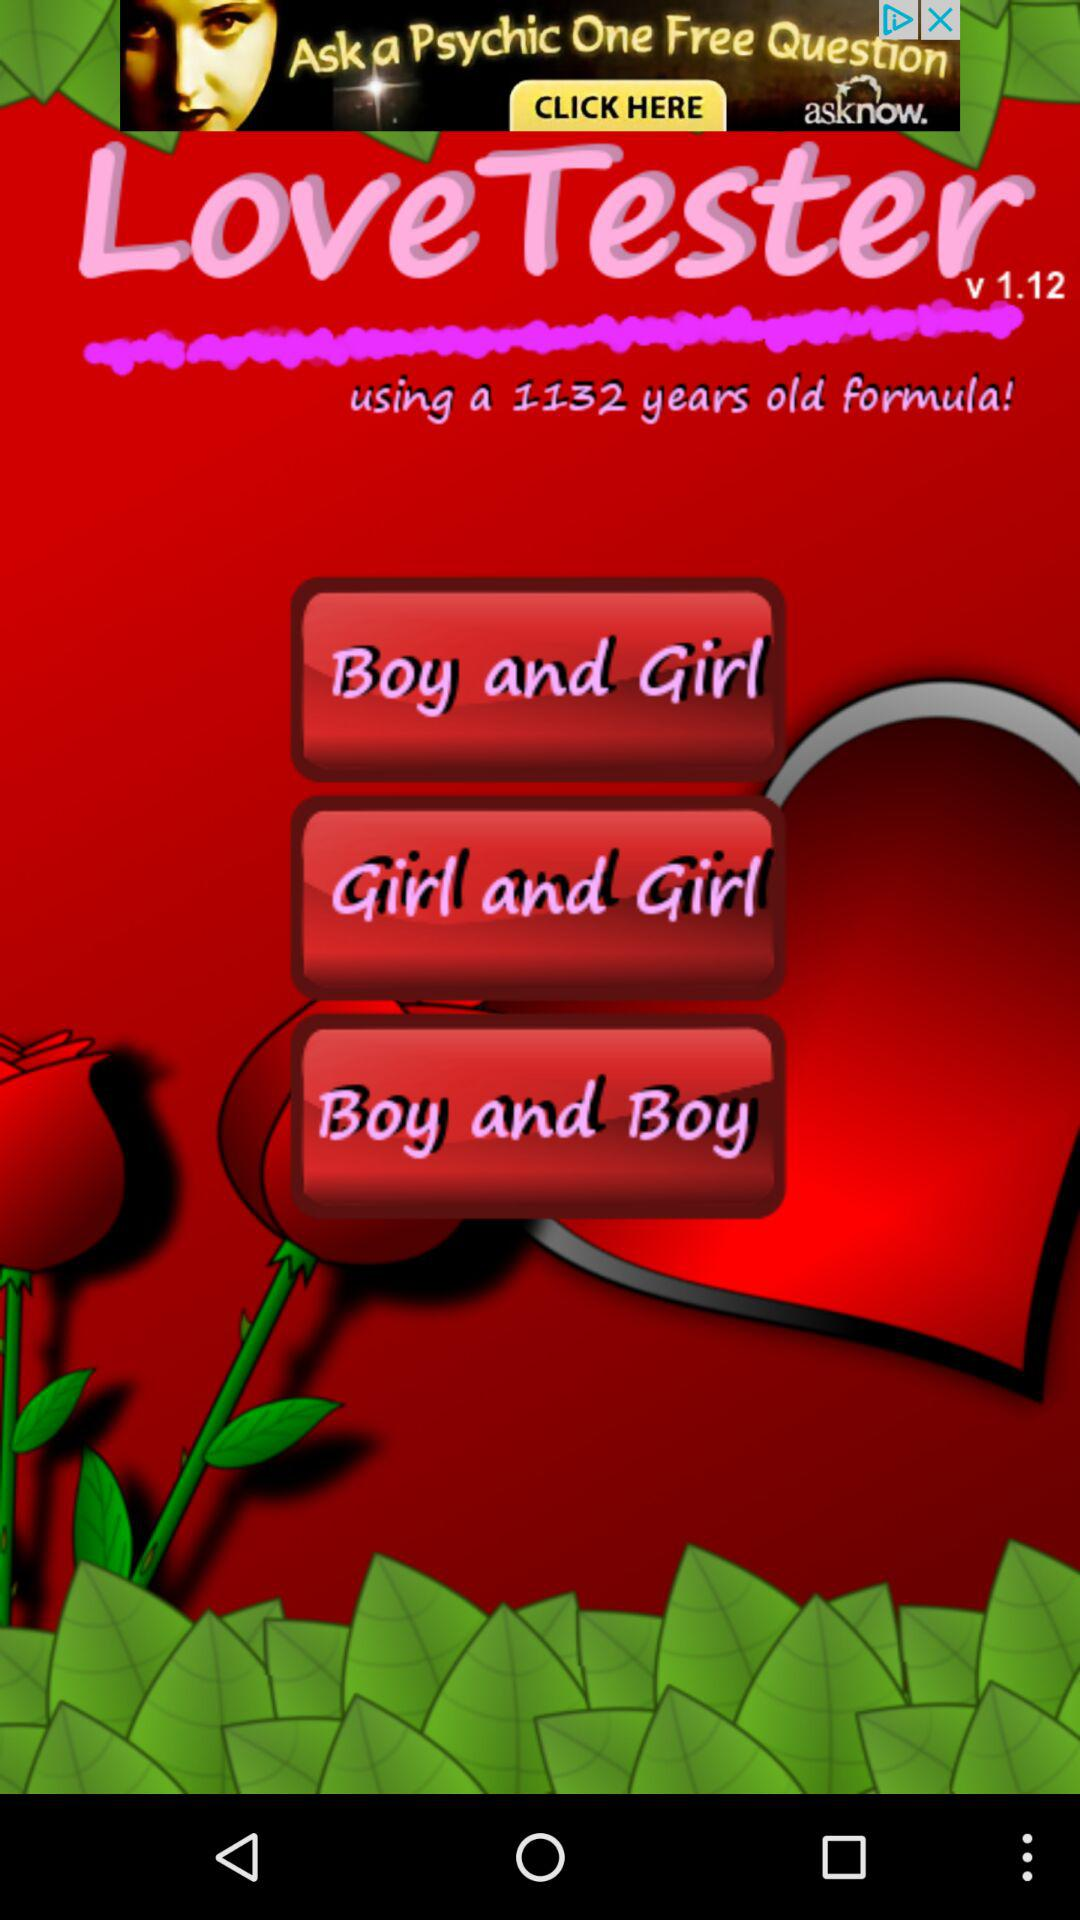How many years old is the formula being used by this application? The formula being used by this application is 1132 years old. 